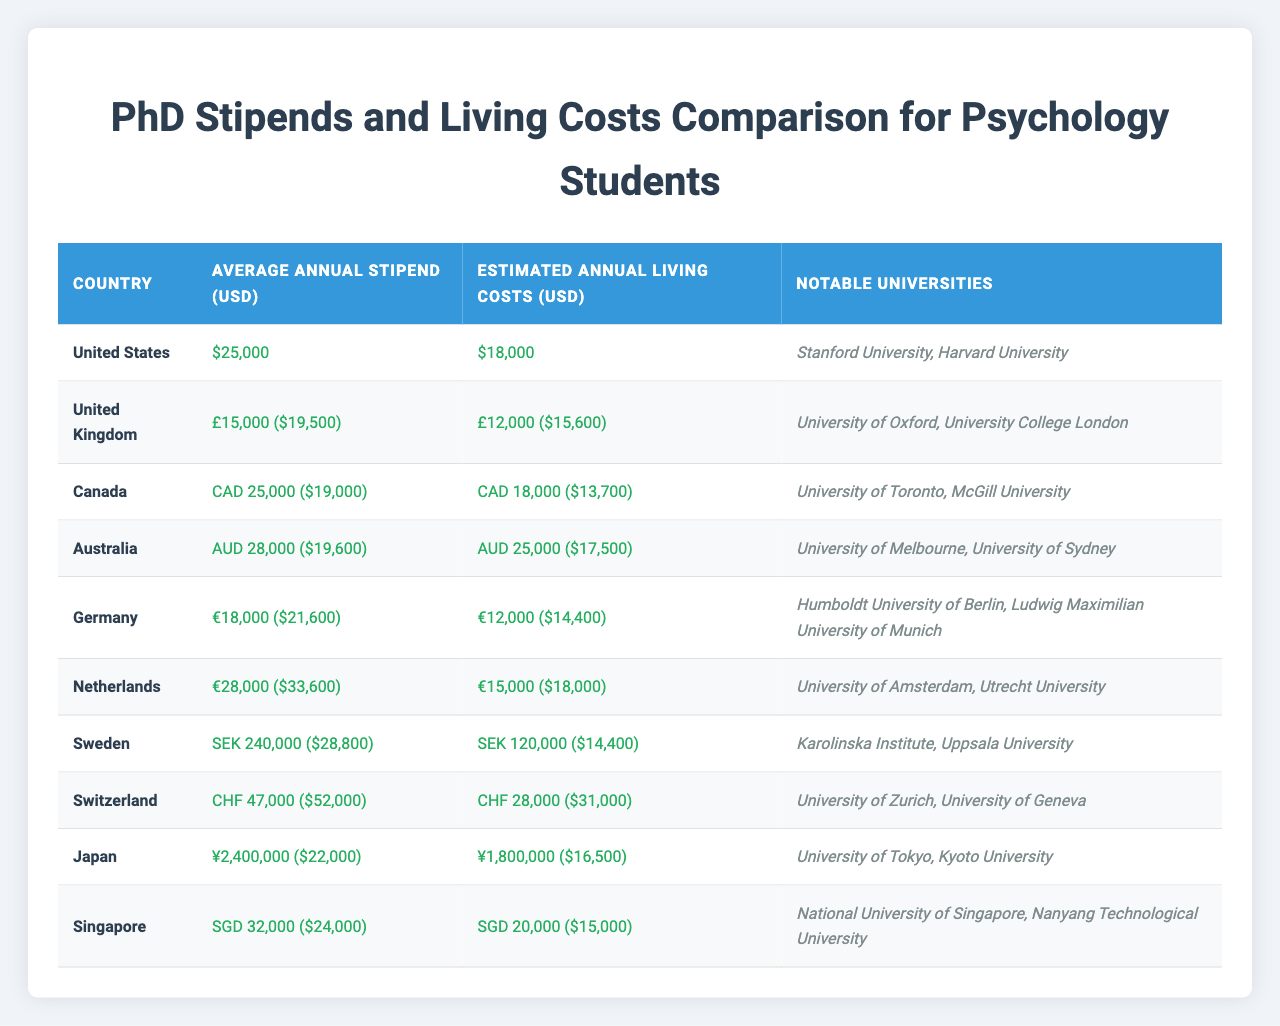What is the average annual stipend for psychology PhD students in the United States? The table shows that the Average Annual Stipend for the United States is $25,000.
Answer: $25,000 Which country has the highest estimated annual living costs? By comparing the Estimated Annual Living Costs for each country, Switzerland has the highest living costs at $31,000.
Answer: $31,000 What is the stipend-to-cost ratio for Australia? The stipend for Australia is $19,600, and the living cost is $17,500. The ratio is 19,600 / 17,500 ≈ 1.12, indicating that the stipend is approximately 12% higher than the living cost.
Answer: Approximately 1.12 Does Germany have a higher stipend compared to the United Kingdom? Germany's Average Annual Stipend is $21,600 while the UK's is $19,500. Since $21,600 is greater than $19,500, the statement is true.
Answer: Yes How much more is the estimated annual living cost in the Netherlands compared to Canada? The Estimated Annual Living Cost in the Netherlands is $18,000, and in Canada, it is $13,700. The difference is 18,000 - 13,700 = $4,300.
Answer: $4,300 Which country offers the lowest stipend among the listed countries? By reviewing the stipends, the United Kingdom's stipend of $19,500 is the lowest.
Answer: $19,500 What country has the most notable universities listed for psychology PhD programs? The United States lists Stanford University and Harvard University, which are both renowned, but the Netherlands also lists two prestigious institutions: University of Amsterdam and Utrecht University. However, the US is recognized more globally in terms of notable institutions.
Answer: United States Can you find the average estimated living cost across all countries? First, calculate the total living costs: $18,000 + $15,600 + $13,700 + $17,500 + $14,400 + $18,000 + $14,400 + $31,000 + $16,500 + $15,000 = $ 158,600. This value is then divided by 10 (the number of countries) which gives an average of 158,600 / 10 = $15,860.
Answer: $15,860 Which country has the largest difference between stipend and living costs? Comparing the stipend and living costs, Switzerland has a stipend of $52,000 and living costs of $31,000, resulting in a difference of 52,000 - 31,000 = $21,000. This is the largest difference noted in the table.
Answer: $21,000 Is the average stipend in Sweden higher than that in Singapore? Sweden's average stipend equates to $28,800, while Singapore's is $24,000. Since $28,800 is indeed more than $24,000, the answer is yes.
Answer: Yes 